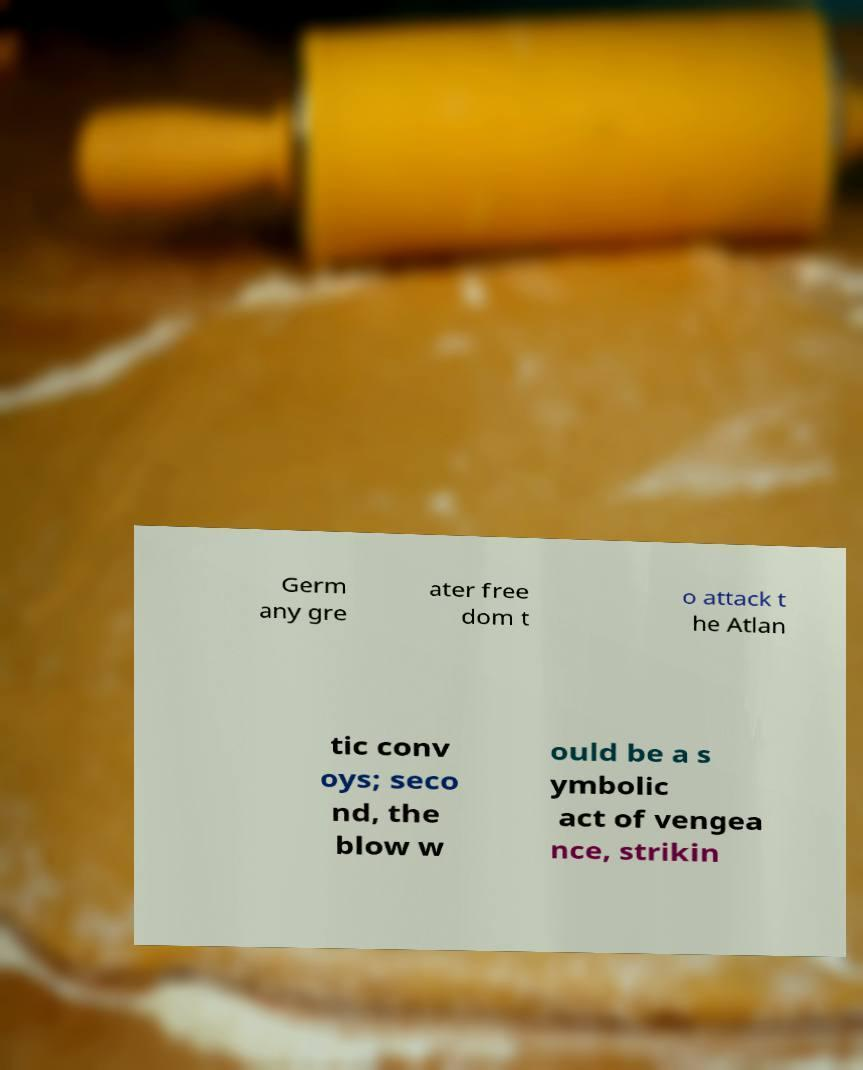For documentation purposes, I need the text within this image transcribed. Could you provide that? Germ any gre ater free dom t o attack t he Atlan tic conv oys; seco nd, the blow w ould be a s ymbolic act of vengea nce, strikin 